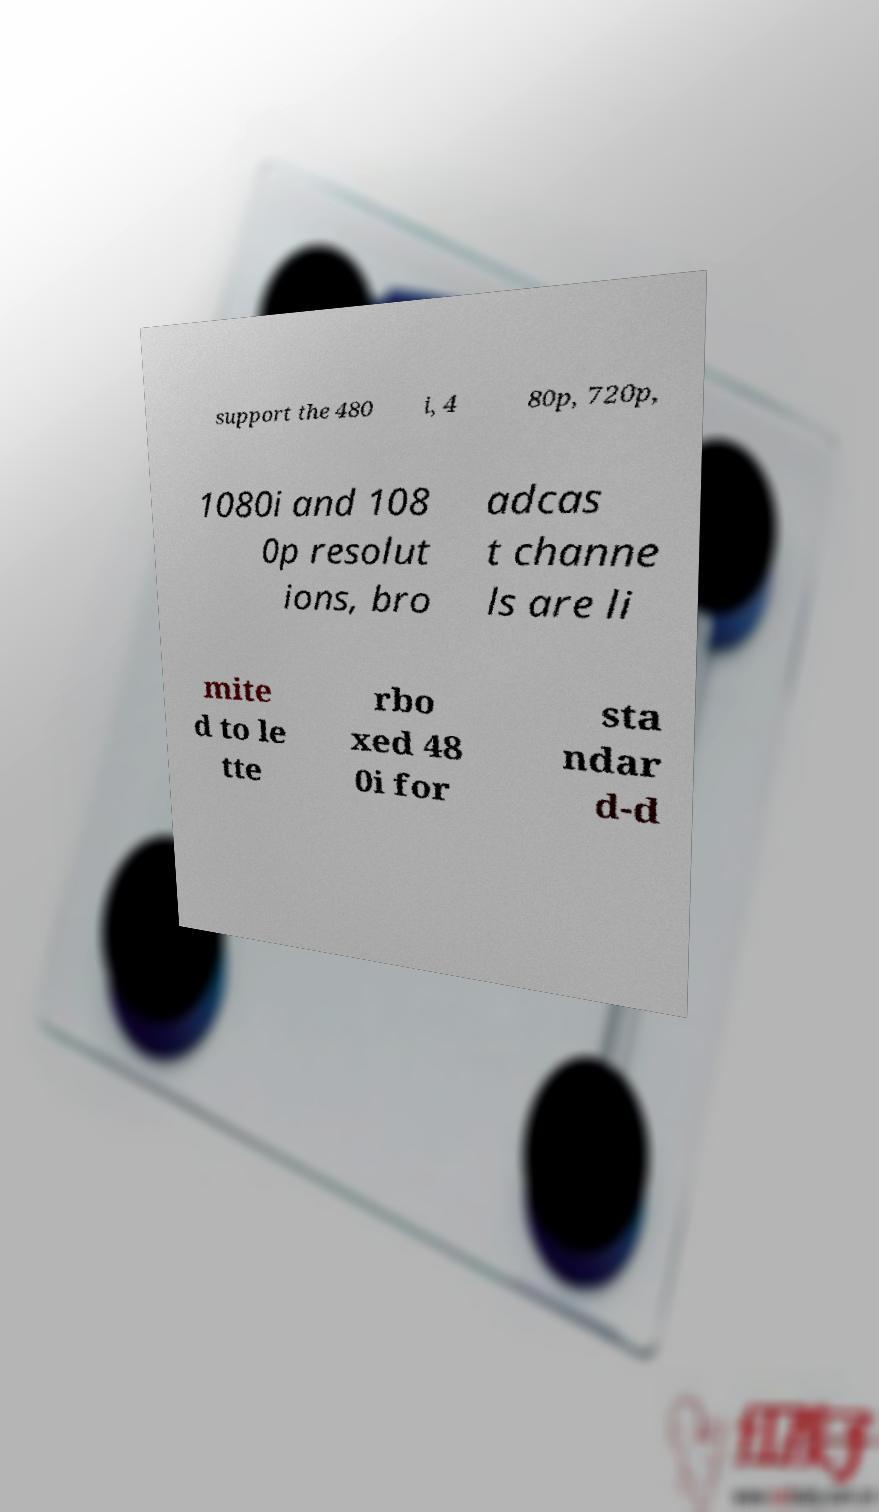Could you assist in decoding the text presented in this image and type it out clearly? support the 480 i, 4 80p, 720p, 1080i and 108 0p resolut ions, bro adcas t channe ls are li mite d to le tte rbo xed 48 0i for sta ndar d-d 